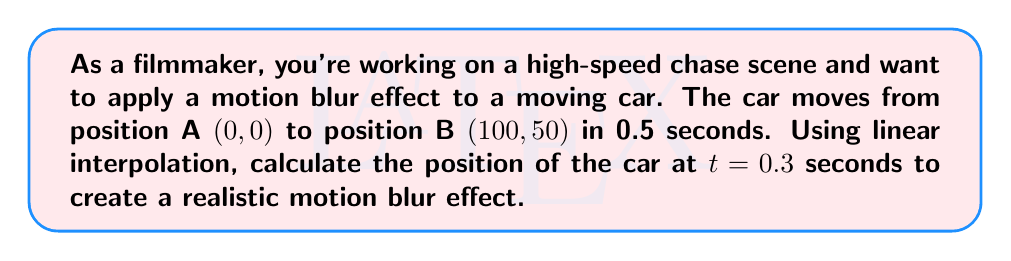Could you help me with this problem? To solve this problem, we'll use linear interpolation between the two known positions. The general formula for linear interpolation is:

$$P(t) = P_1 + t(P_2 - P_1)$$

Where:
- $P(t)$ is the interpolated position at time $t$
- $P_1$ is the initial position
- $P_2$ is the final position
- $t$ is the normalized time (between 0 and 1)

Given:
- Initial position $P_1 = (0, 0)$
- Final position $P_2 = (100, 50)$
- Total time = 0.5 seconds
- We want to find the position at $t = 0.3$ seconds

Step 1: Normalize the time
Normalized time = $\frac{0.3}{0.5} = 0.6$

Step 2: Apply the linear interpolation formula for x-coordinate
$$x = 0 + 0.6(100 - 0) = 60$$

Step 3: Apply the linear interpolation formula for y-coordinate
$$y = 0 + 0.6(50 - 0) = 30$$

Therefore, the position of the car at $t = 0.3$ seconds is $(60, 30)$.
Answer: $(60, 30)$ 